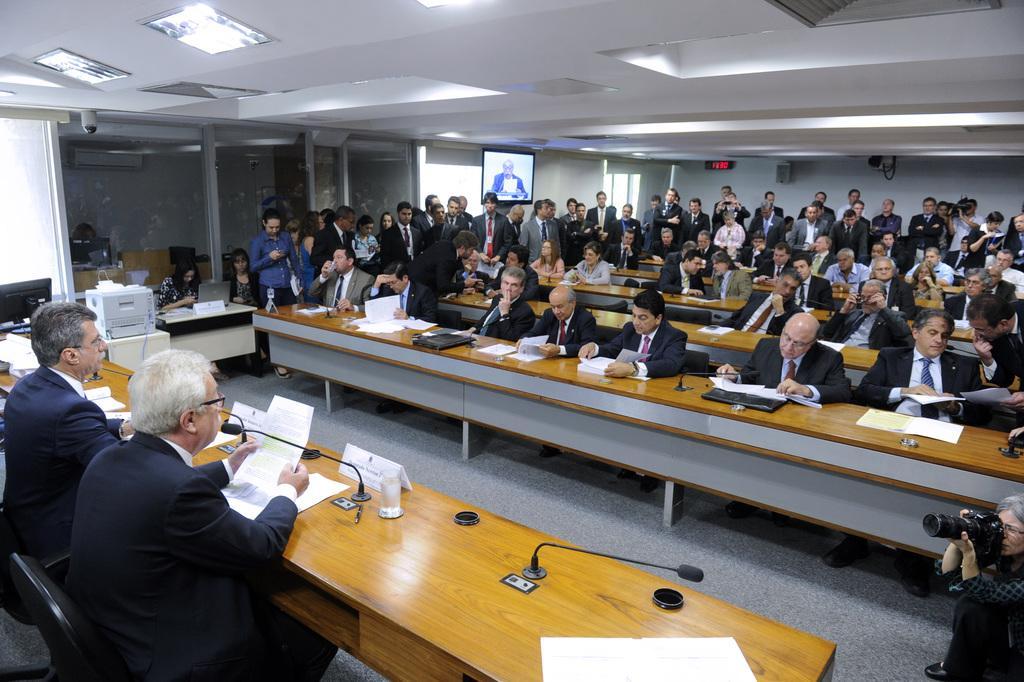Can you describe this image briefly? In the picture I can see a group of people. I can see a few of them sitting on the chairs and a few of them standing on the floor. I can see the wooden tables and chairs on the floor. I can see the files, papers and microphones on the table. I can see a woman on the bottom right side and she is holding the camera. I can see a television on the wall. There is a lighting arrangement on the roof. I can see a computer on the table on the left side. I can see the glass windows and there is a woman sitting on the chair and working on a laptop. 